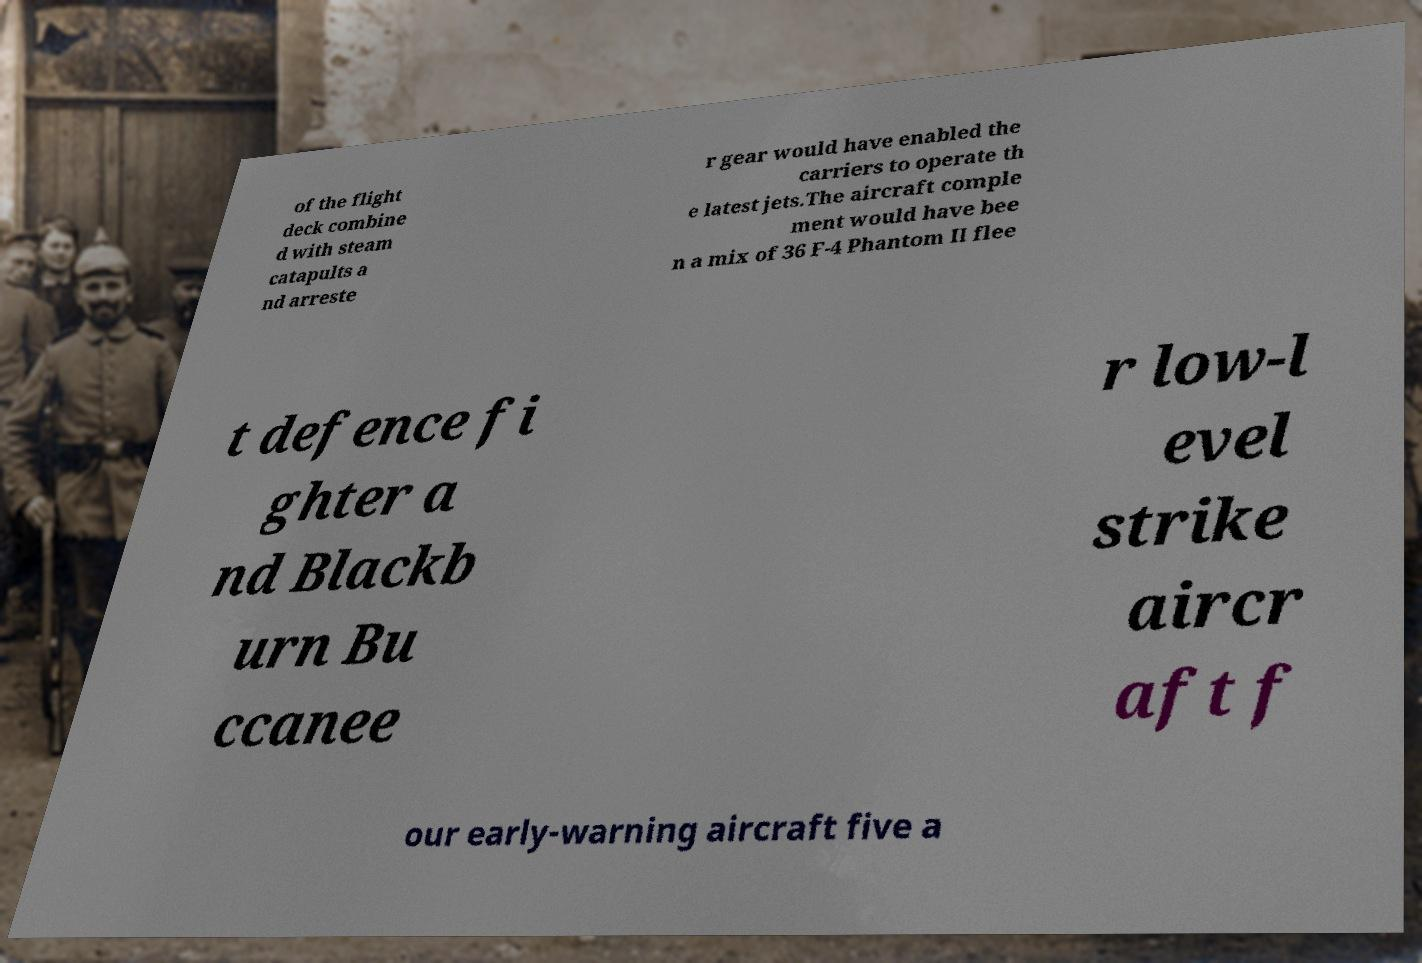I need the written content from this picture converted into text. Can you do that? of the flight deck combine d with steam catapults a nd arreste r gear would have enabled the carriers to operate th e latest jets.The aircraft comple ment would have bee n a mix of 36 F-4 Phantom II flee t defence fi ghter a nd Blackb urn Bu ccanee r low-l evel strike aircr aft f our early-warning aircraft five a 